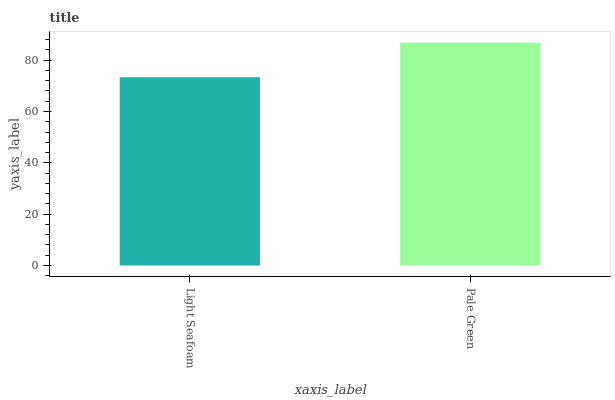Is Light Seafoam the minimum?
Answer yes or no. Yes. Is Pale Green the maximum?
Answer yes or no. Yes. Is Pale Green the minimum?
Answer yes or no. No. Is Pale Green greater than Light Seafoam?
Answer yes or no. Yes. Is Light Seafoam less than Pale Green?
Answer yes or no. Yes. Is Light Seafoam greater than Pale Green?
Answer yes or no. No. Is Pale Green less than Light Seafoam?
Answer yes or no. No. Is Pale Green the high median?
Answer yes or no. Yes. Is Light Seafoam the low median?
Answer yes or no. Yes. Is Light Seafoam the high median?
Answer yes or no. No. Is Pale Green the low median?
Answer yes or no. No. 